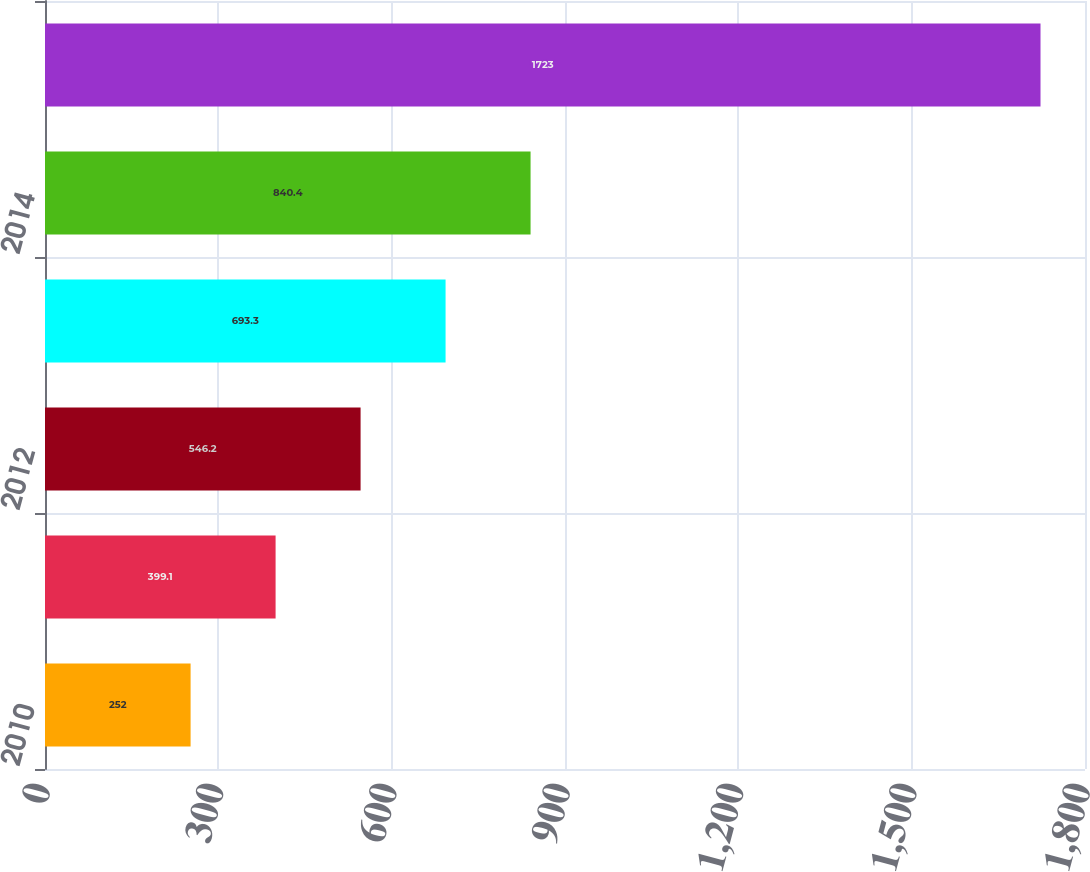Convert chart. <chart><loc_0><loc_0><loc_500><loc_500><bar_chart><fcel>2010<fcel>2011<fcel>2012<fcel>2013<fcel>2014<fcel>2015 to 2019<nl><fcel>252<fcel>399.1<fcel>546.2<fcel>693.3<fcel>840.4<fcel>1723<nl></chart> 